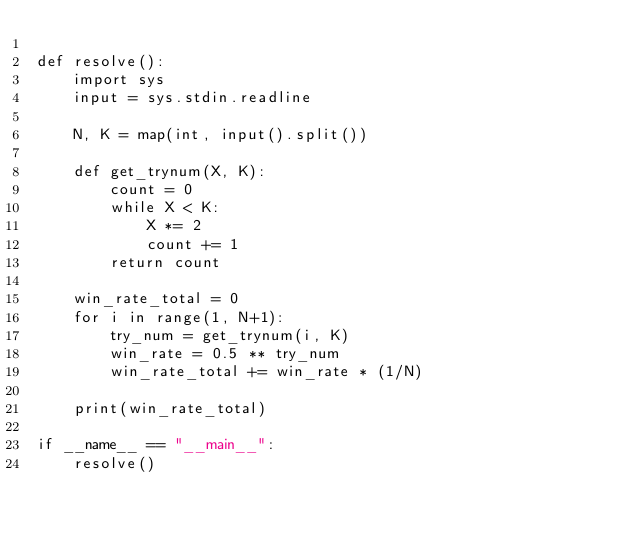Convert code to text. <code><loc_0><loc_0><loc_500><loc_500><_Python_>
def resolve():
    import sys
    input = sys.stdin.readline
    
    N, K = map(int, input().split())

    def get_trynum(X, K):
        count = 0
        while X < K:
            X *= 2
            count += 1
        return count

    win_rate_total = 0
    for i in range(1, N+1):
        try_num = get_trynum(i, K)
        win_rate = 0.5 ** try_num 
        win_rate_total += win_rate * (1/N)
    
    print(win_rate_total)

if __name__ == "__main__":
    resolve()</code> 